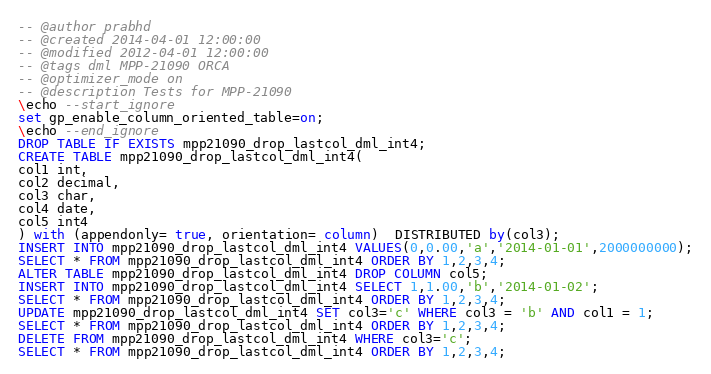Convert code to text. <code><loc_0><loc_0><loc_500><loc_500><_SQL_>-- @author prabhd 
-- @created 2014-04-01 12:00:00
-- @modified 2012-04-01 12:00:00
-- @tags dml MPP-21090 ORCA
-- @optimizer_mode on	
-- @description Tests for MPP-21090
\echo --start_ignore
set gp_enable_column_oriented_table=on;
\echo --end_ignore
DROP TABLE IF EXISTS mpp21090_drop_lastcol_dml_int4;
CREATE TABLE mpp21090_drop_lastcol_dml_int4(
col1 int,
col2 decimal,
col3 char,
col4 date,
col5 int4
) with (appendonly= true, orientation= column)  DISTRIBUTED by(col3);
INSERT INTO mpp21090_drop_lastcol_dml_int4 VALUES(0,0.00,'a','2014-01-01',2000000000);
SELECT * FROM mpp21090_drop_lastcol_dml_int4 ORDER BY 1,2,3,4;
ALTER TABLE mpp21090_drop_lastcol_dml_int4 DROP COLUMN col5;
INSERT INTO mpp21090_drop_lastcol_dml_int4 SELECT 1,1.00,'b','2014-01-02';
SELECT * FROM mpp21090_drop_lastcol_dml_int4 ORDER BY 1,2,3,4;
UPDATE mpp21090_drop_lastcol_dml_int4 SET col3='c' WHERE col3 = 'b' AND col1 = 1;
SELECT * FROM mpp21090_drop_lastcol_dml_int4 ORDER BY 1,2,3,4;
DELETE FROM mpp21090_drop_lastcol_dml_int4 WHERE col3='c';
SELECT * FROM mpp21090_drop_lastcol_dml_int4 ORDER BY 1,2,3,4;

</code> 